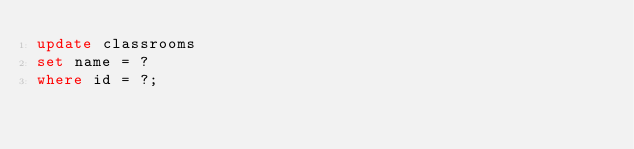<code> <loc_0><loc_0><loc_500><loc_500><_SQL_>update classrooms
set name = ?
where id = ?;
</code> 